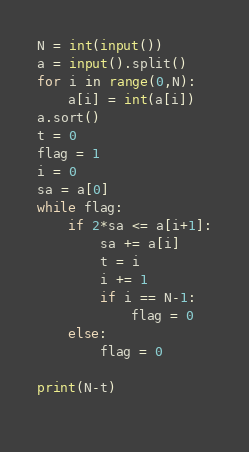<code> <loc_0><loc_0><loc_500><loc_500><_Python_>N = int(input())
a = input().split()
for i in range(0,N):
	a[i] = int(a[i])
a.sort()
t = 0
flag = 1
i = 0
sa = a[0]
while flag:
	if 2*sa <= a[i+1]:
		sa += a[i]
		t = i
		i += 1
		if i == N-1: 
			flag = 0
	else:
		flag = 0
		
print(N-t)
		</code> 